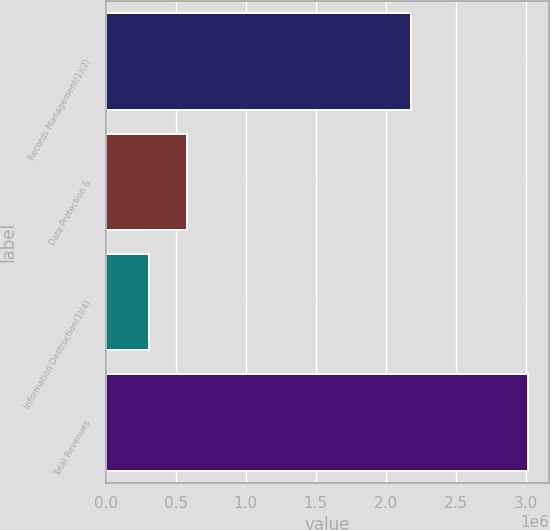Convert chart to OTSL. <chart><loc_0><loc_0><loc_500><loc_500><bar_chart><fcel>Records Management(1)(2)<fcel>Data Protection &<fcel>Information Destruction(1)(4)<fcel>Total Revenues<nl><fcel>2.18315e+06<fcel>579496<fcel>308917<fcel>3.0147e+06<nl></chart> 